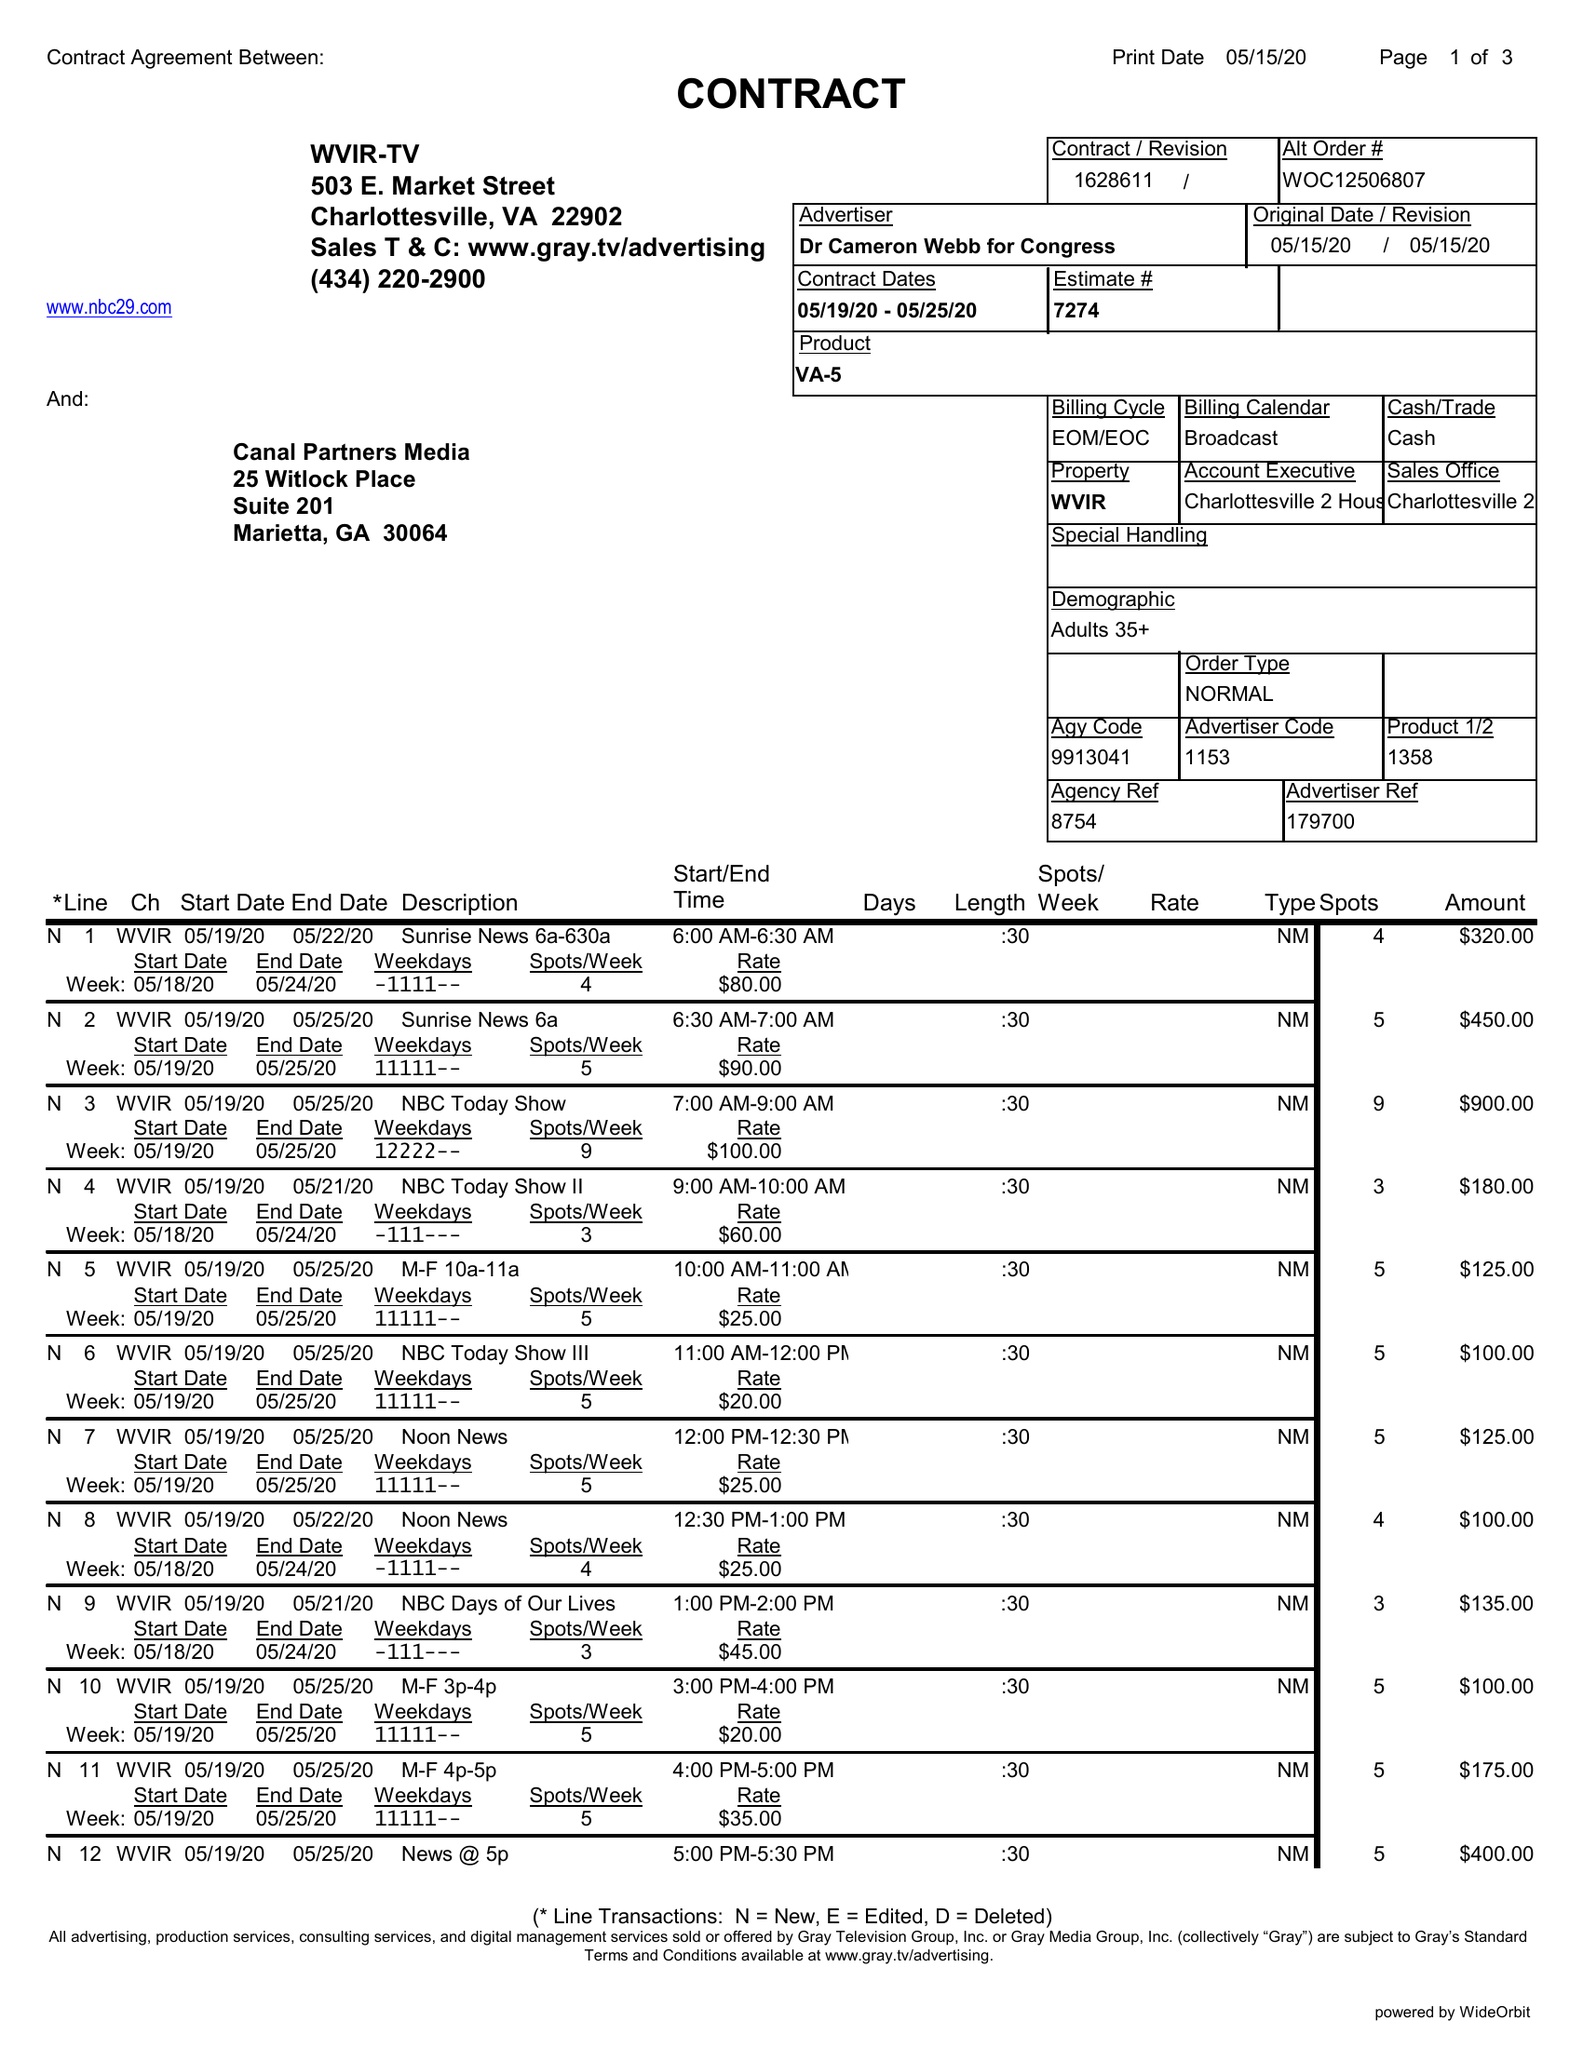What is the value for the gross_amount?
Answer the question using a single word or phrase. 7340.00 